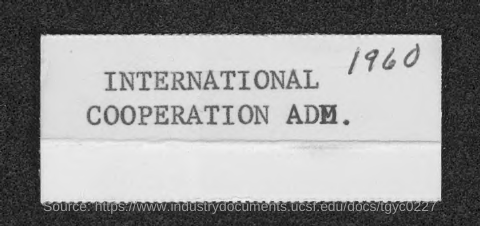Identify some key points in this picture. The year shown in the document is 1960. 